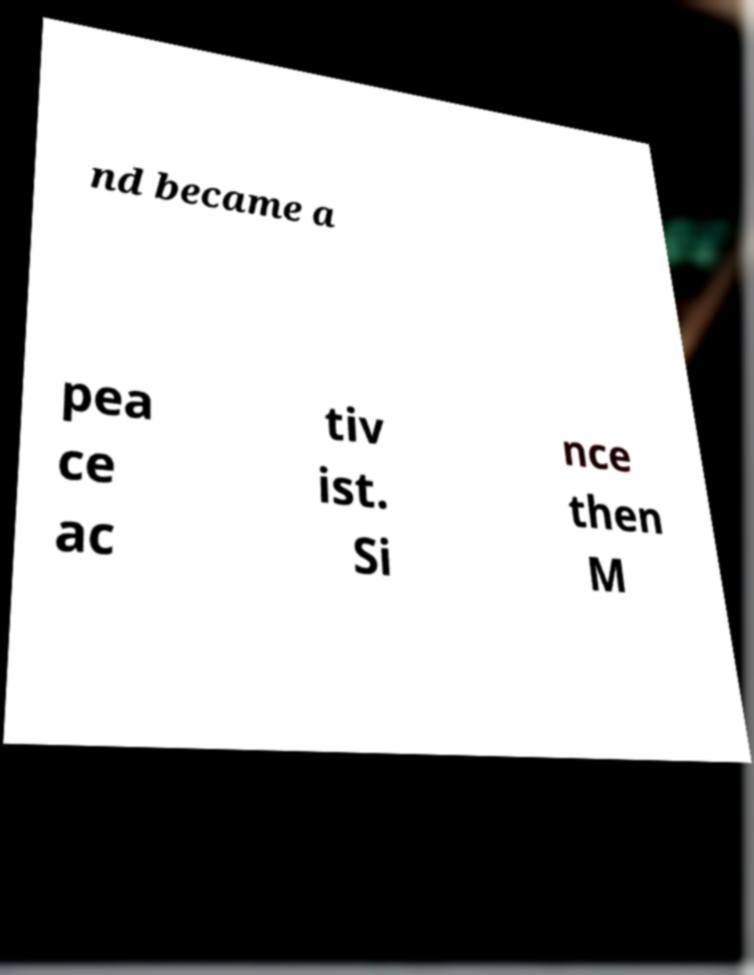Can you accurately transcribe the text from the provided image for me? nd became a pea ce ac tiv ist. Si nce then M 